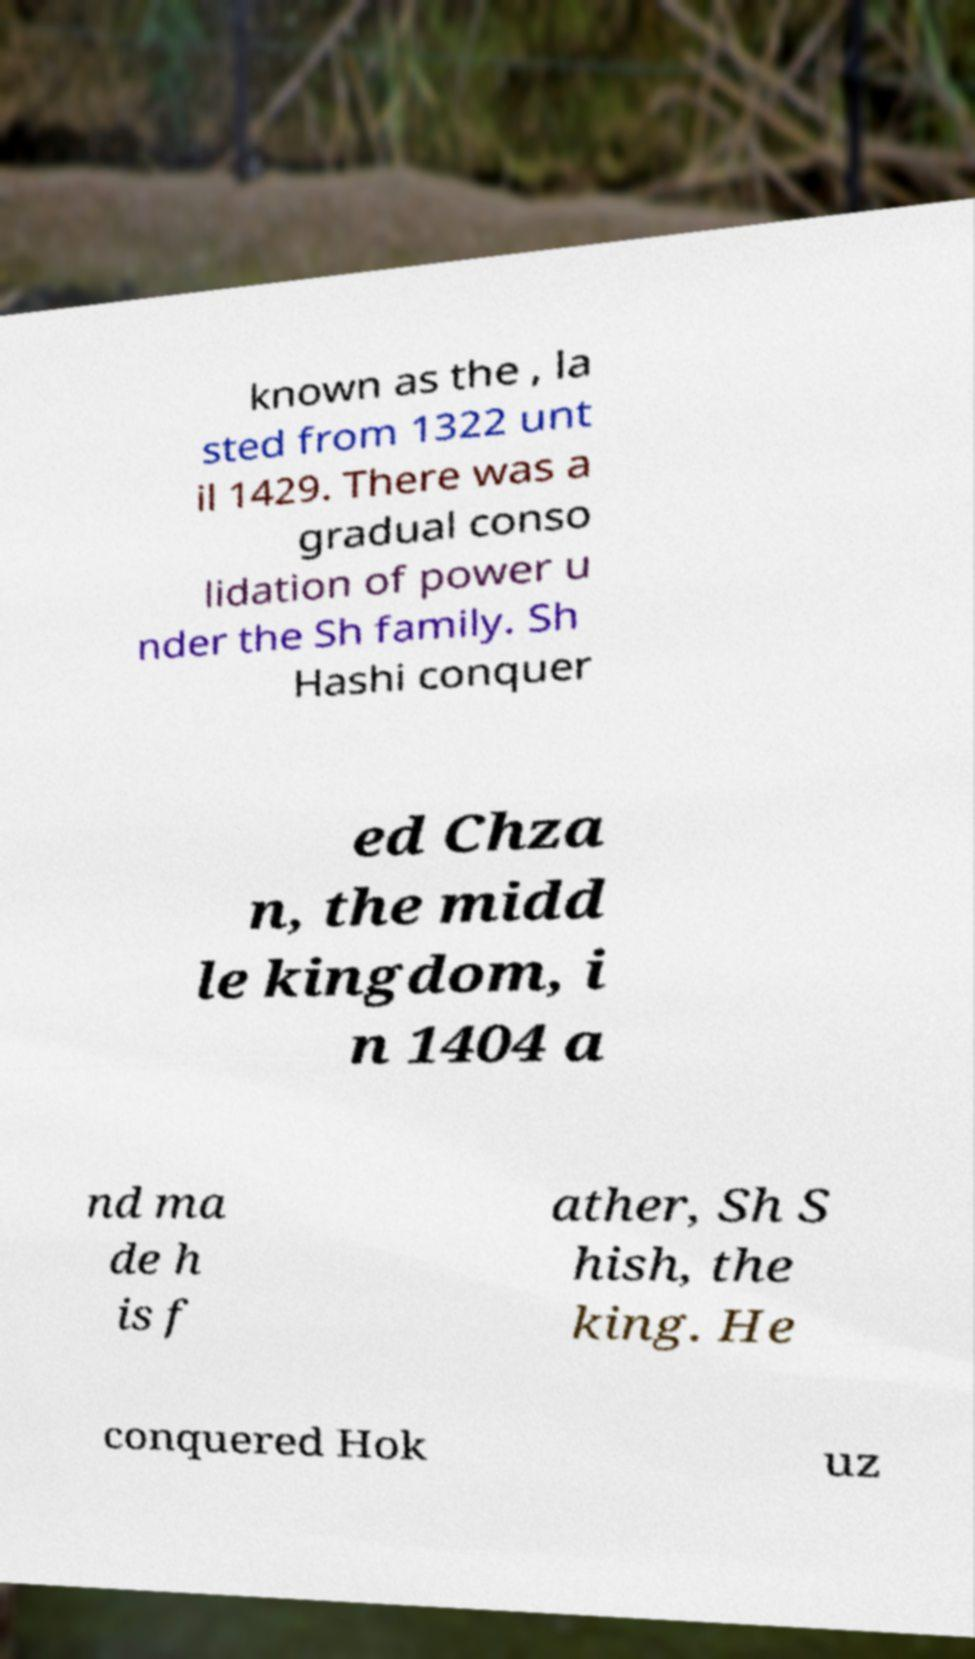Please identify and transcribe the text found in this image. known as the , la sted from 1322 unt il 1429. There was a gradual conso lidation of power u nder the Sh family. Sh Hashi conquer ed Chza n, the midd le kingdom, i n 1404 a nd ma de h is f ather, Sh S hish, the king. He conquered Hok uz 